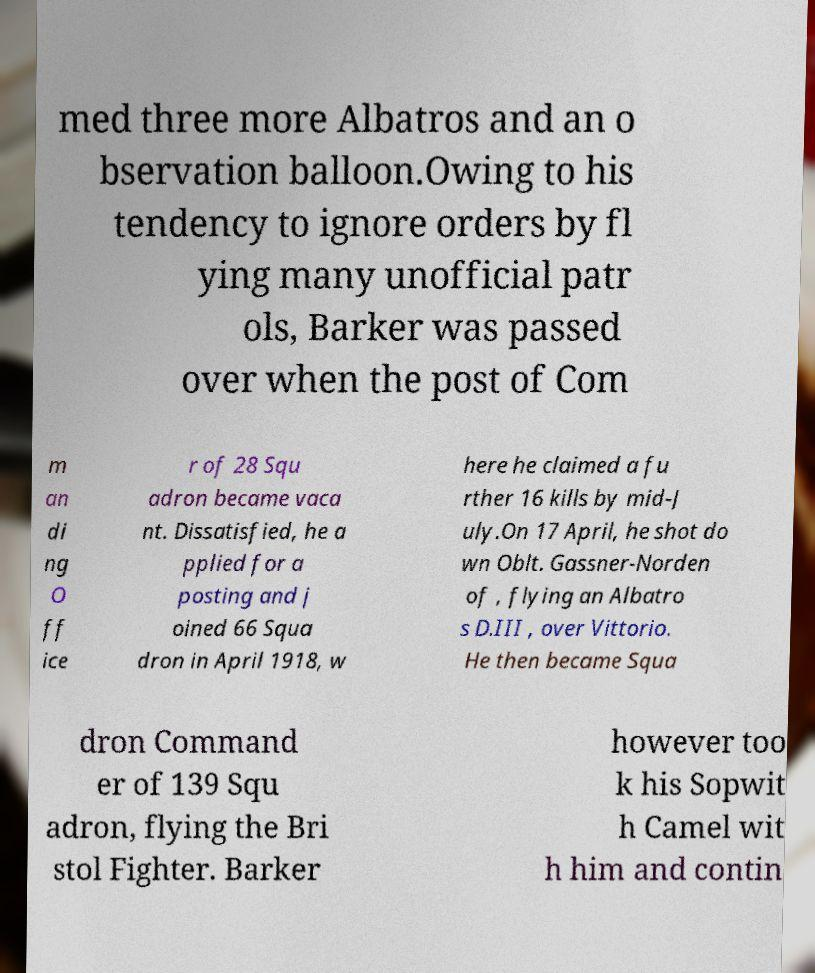Can you accurately transcribe the text from the provided image for me? med three more Albatros and an o bservation balloon.Owing to his tendency to ignore orders by fl ying many unofficial patr ols, Barker was passed over when the post of Com m an di ng O ff ice r of 28 Squ adron became vaca nt. Dissatisfied, he a pplied for a posting and j oined 66 Squa dron in April 1918, w here he claimed a fu rther 16 kills by mid-J uly.On 17 April, he shot do wn Oblt. Gassner-Norden of , flying an Albatro s D.III , over Vittorio. He then became Squa dron Command er of 139 Squ adron, flying the Bri stol Fighter. Barker however too k his Sopwit h Camel wit h him and contin 